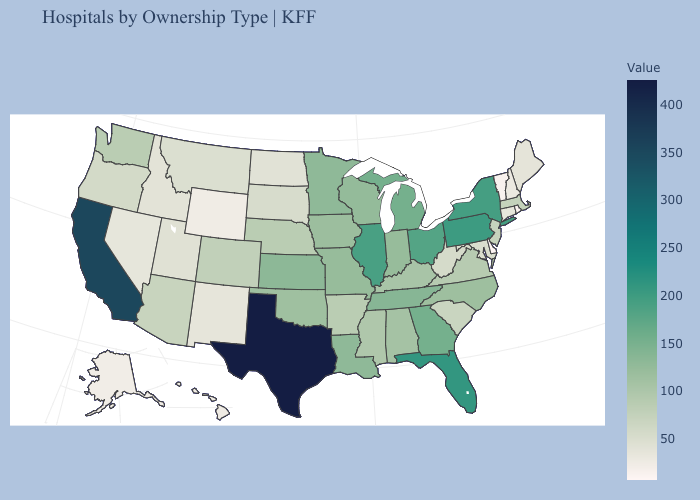Does South Dakota have the lowest value in the USA?
Concise answer only. No. Which states have the lowest value in the USA?
Write a very short answer. Delaware. Among the states that border California , which have the highest value?
Give a very brief answer. Arizona. Which states hav the highest value in the West?
Short answer required. California. Among the states that border Vermont , does Massachusetts have the lowest value?
Be succinct. No. 